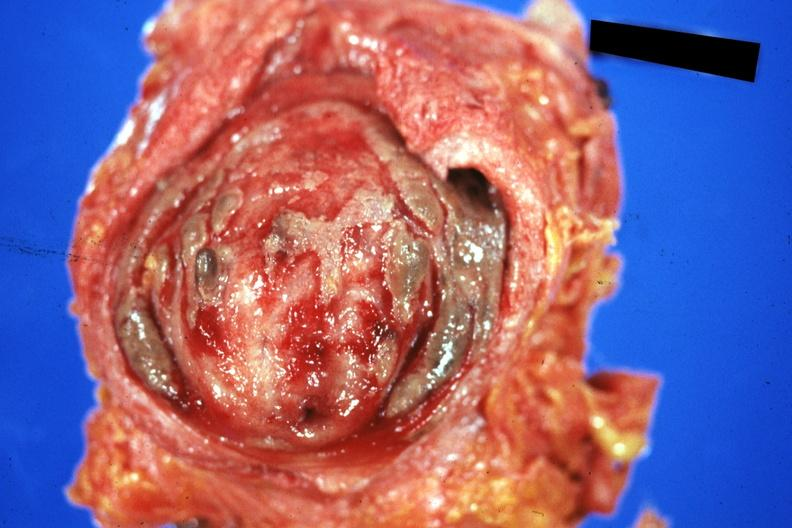does le cell show mucosal surface quite good?
Answer the question using a single word or phrase. No 